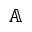<formula> <loc_0><loc_0><loc_500><loc_500>\mathbb { A }</formula> 